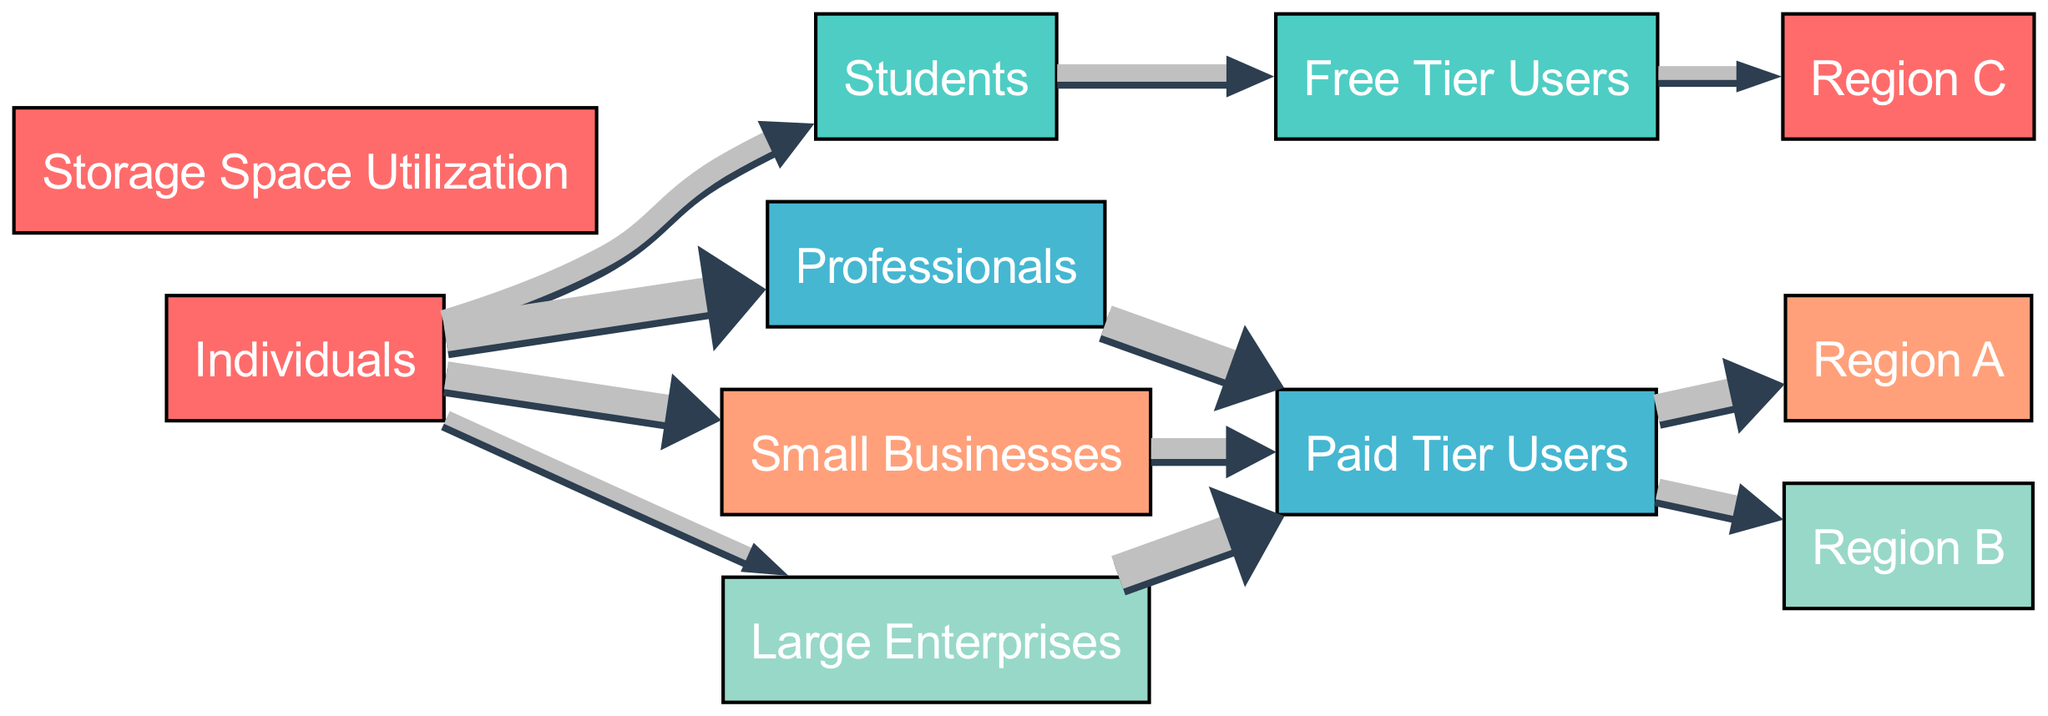What percentage of individual users are students? From the diagram, it shows that there are 30 students out of a total of 140 individuals (30 students + 50 professionals + 40 small businesses + 20 large enterprises). To find the percentage, we calculate (30/140) * 100, which equals approximately 21.43%.
Answer: 21.43% How many individuals are categorized as large enterprises? The diagram shows a direct edge from "Individuals" to "Large Enterprises" with a value of 20. This represents the number of individuals in the large enterprise category.
Answer: 20 Which user group has the highest storage space utilization? Upon reviewing the links leading to "Storage Space Utilization," the "Paid Tier Users" category receives connections from three user groups: Professionals (45), Small Businesses (30), and Large Enterprises (50). The sum of these connections shows that Large Enterprises have the highest individual contribution of 50.
Answer: Large Enterprises What is the total number of paid tier users? To determine the total, we add the values from the user groups contributing to "Paid Tier Users": Professionals (45), Small Businesses (30), and Large Enterprises (50). The calculation is 45 + 30 + 50 = 125, indicating the total number of paid tier users.
Answer: 125 Which region has the lowest data utilization from paid users? Looking at the links from "Paid Tier Users" to the regions, Region A has a utilization of 40, Region B 30, and Region C does not receive any paid tier users. Since Region B has the lowest value among the utilized regions, it indicates the lowest level of data utilization from paid users.
Answer: Region B How many total distinct user groups are represented in the diagram? By counting the nodes listed in the diagram, there are 5 distinct user groups represented: Students, Professionals, Small Businesses, Large Enterprises, and Individuals. Therefore, the distinct user groups total is 5.
Answer: 5 What proportion of free tier users are associated with Region C? According to the diagram, "Free Tier Users" has an outgoing link to "Region C" with a value of 20. This is the only region targeted by free tier users, and since there are no other connections, they constitute 100% of free tier user utilization.
Answer: 100% What is the total storage space utilization for small businesses? Examining the diagram, Small Businesses have a direct link to "Paid Tier Users" with a value of 30. Thus, the total storage space utilization coming from small businesses is represented by this value.
Answer: 30 